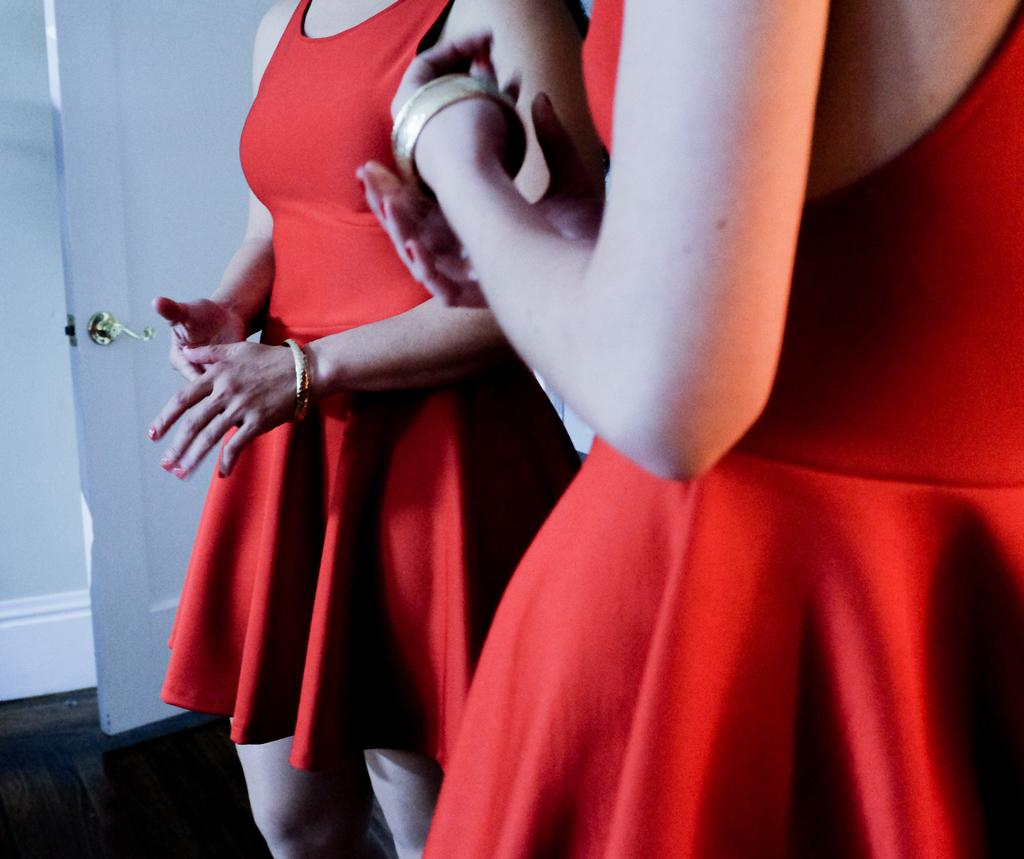How many people are in the image? There are persons in the image, but the exact number is not specified. What are the persons doing in the image? The persons are standing on the floor. Do the persons have wings in the image? There is no mention of wings in the image, so it cannot be determined if the persons have wings or not. 